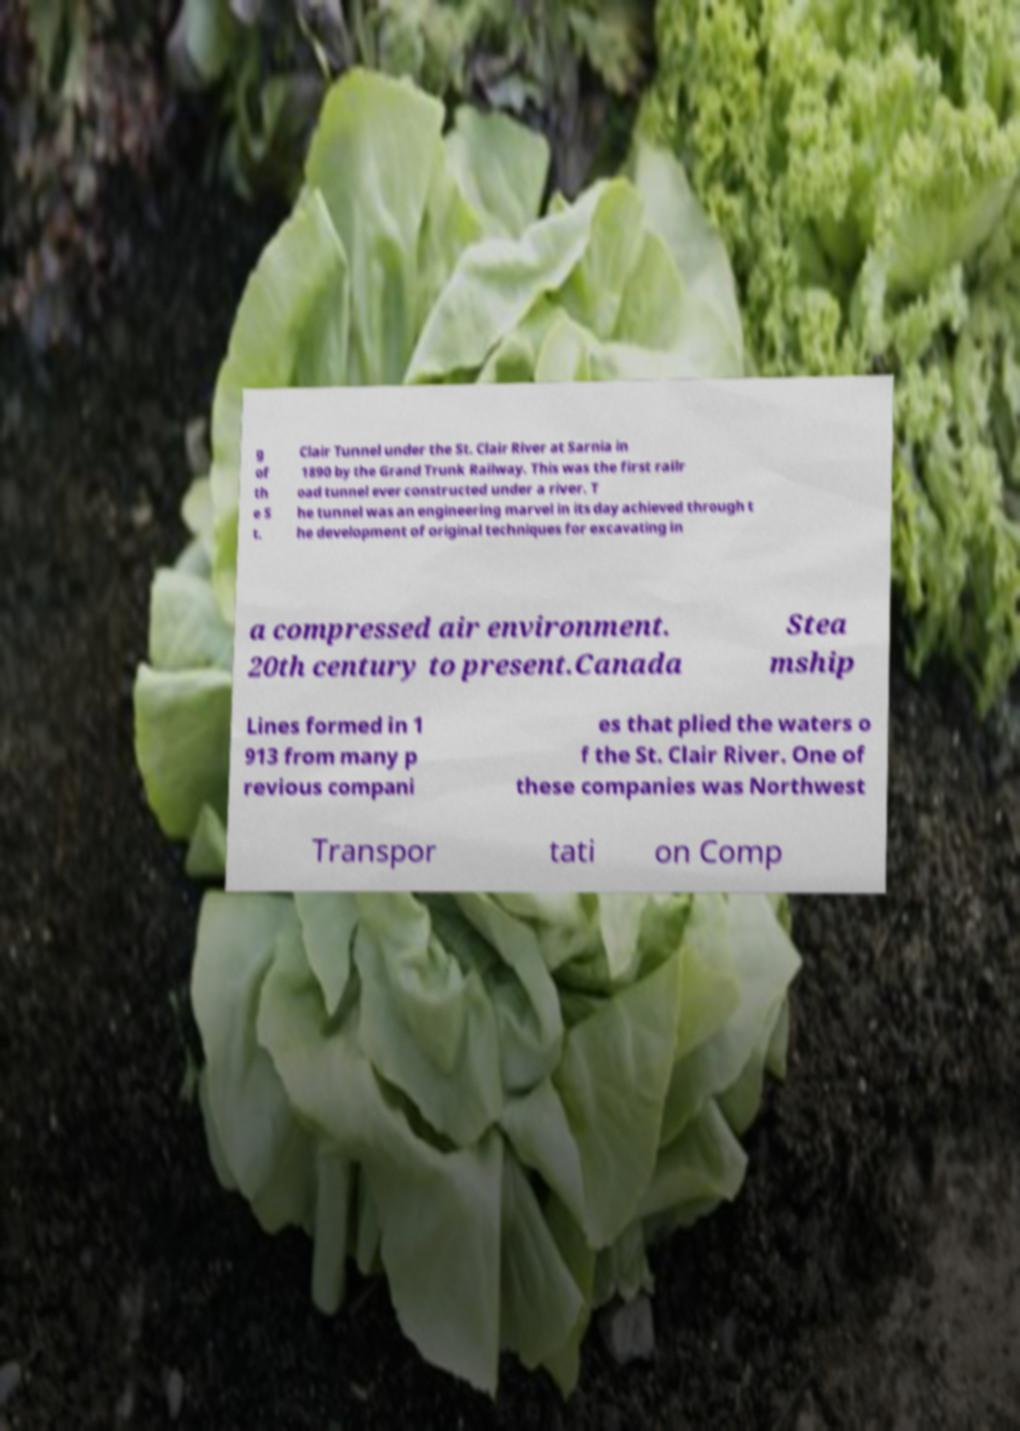Please read and relay the text visible in this image. What does it say? g of th e S t. Clair Tunnel under the St. Clair River at Sarnia in 1890 by the Grand Trunk Railway. This was the first railr oad tunnel ever constructed under a river. T he tunnel was an engineering marvel in its day achieved through t he development of original techniques for excavating in a compressed air environment. 20th century to present.Canada Stea mship Lines formed in 1 913 from many p revious compani es that plied the waters o f the St. Clair River. One of these companies was Northwest Transpor tati on Comp 